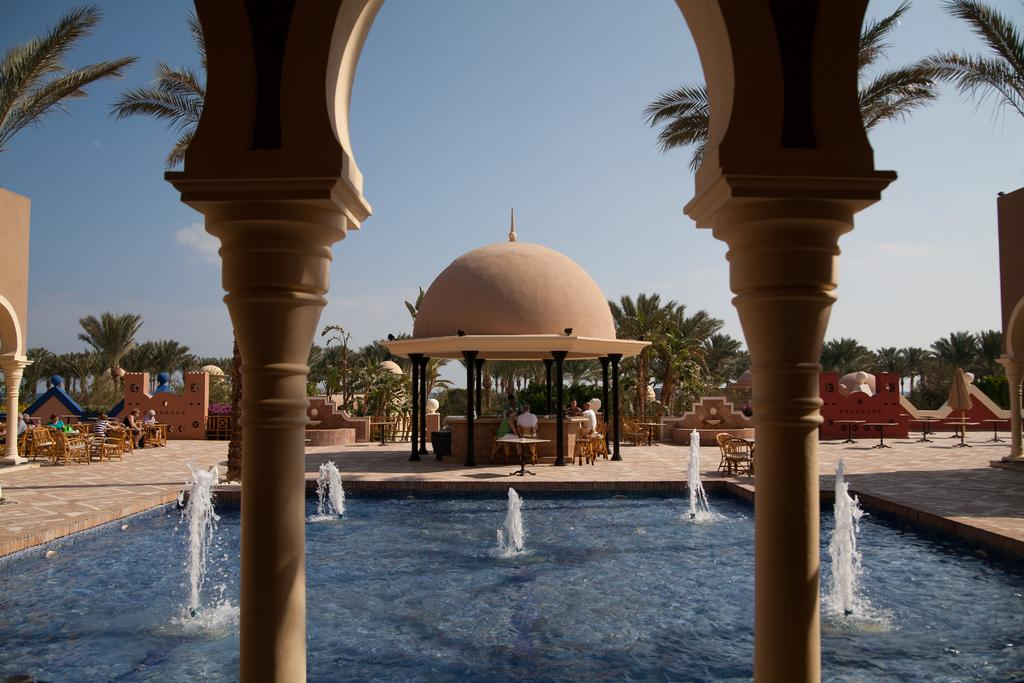What natural feature is the main subject of the image? There is a waterfall in the image. What type of furniture is located on the left side of the image? There are chairs and dining tables on the left side of the image. What can be seen in the background of the image? There are green color trees in the background of the image. What type of yarn is being used to create the river in the image? There is no river present in the image, and therefore no yarn is being used to create it. What is the highest point in the image? The image does not depict a specific location with a highest point, as it primarily features a waterfall and surrounding trees. 